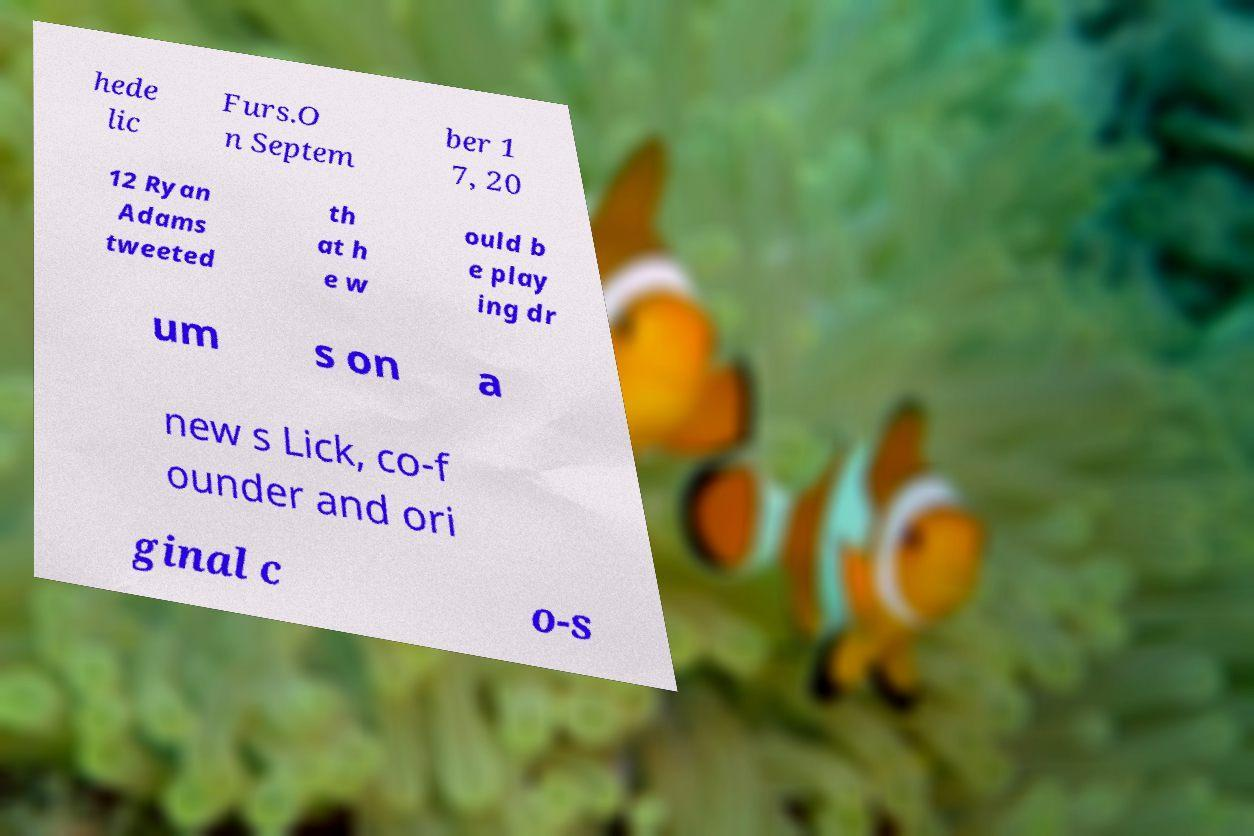Can you read and provide the text displayed in the image?This photo seems to have some interesting text. Can you extract and type it out for me? hede lic Furs.O n Septem ber 1 7, 20 12 Ryan Adams tweeted th at h e w ould b e play ing dr um s on a new s Lick, co-f ounder and ori ginal c o-s 